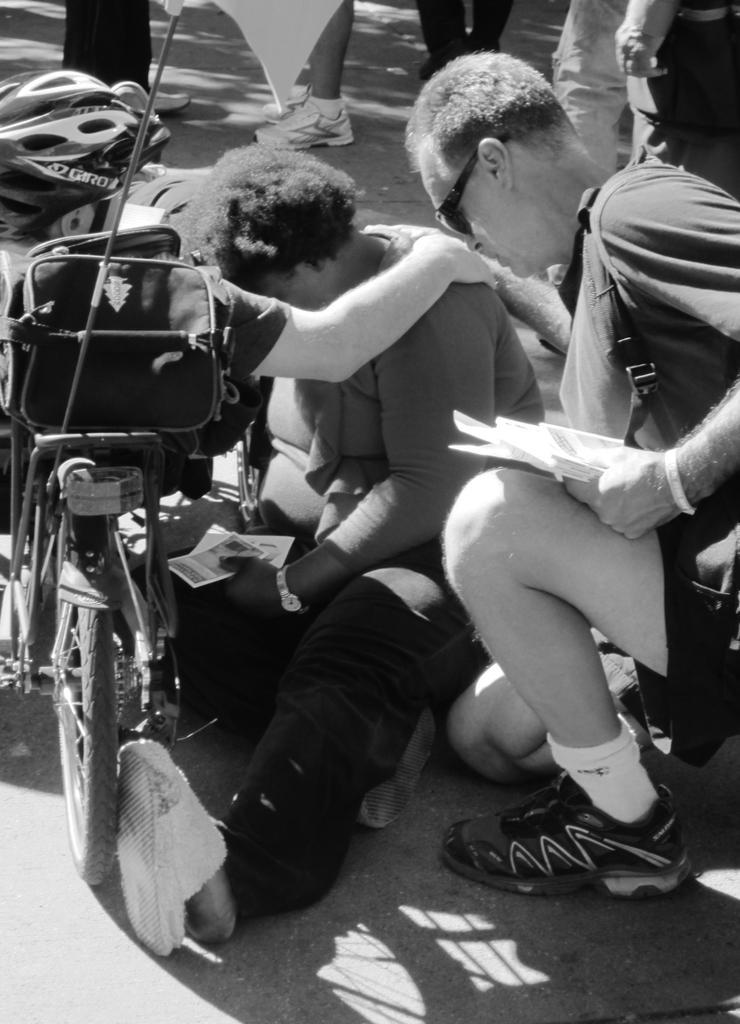Could you give a brief overview of what you see in this image? In this black and white picture there is a person sitting on the floor. Before him there is a vehicle having a bag and a person is sitting on it. He is wearing helmet. Right side there is a person holding few books in his hand. He is carrying a bag. Behind them there are few persons standing on the floor. 